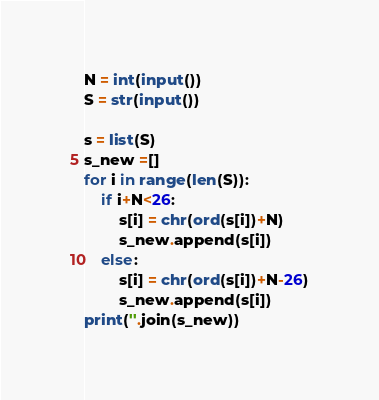<code> <loc_0><loc_0><loc_500><loc_500><_Python_>N = int(input())
S = str(input())

s = list(S)
s_new =[]
for i in range(len(S)):
    if i+N<26:
        s[i] = chr(ord(s[i])+N)
        s_new.append(s[i])
    else:
        s[i] = chr(ord(s[i])+N-26)
        s_new.append(s[i])
print(''.join(s_new))
</code> 